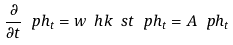<formula> <loc_0><loc_0><loc_500><loc_500>\frac { \partial } { \partial t } \ p h _ { t } = w \ h k \ s t \ p h _ { t } = A \ p h _ { t }</formula> 